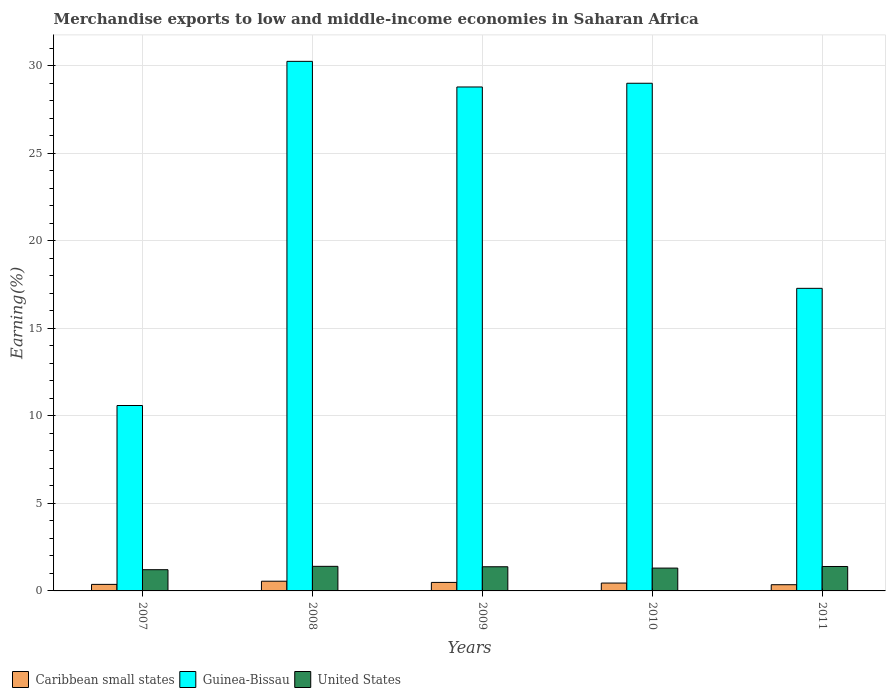How many different coloured bars are there?
Offer a terse response. 3. Are the number of bars per tick equal to the number of legend labels?
Give a very brief answer. Yes. What is the label of the 5th group of bars from the left?
Offer a terse response. 2011. In how many cases, is the number of bars for a given year not equal to the number of legend labels?
Keep it short and to the point. 0. What is the percentage of amount earned from merchandise exports in Guinea-Bissau in 2010?
Provide a succinct answer. 29. Across all years, what is the maximum percentage of amount earned from merchandise exports in Guinea-Bissau?
Keep it short and to the point. 30.25. Across all years, what is the minimum percentage of amount earned from merchandise exports in United States?
Offer a terse response. 1.21. In which year was the percentage of amount earned from merchandise exports in United States minimum?
Provide a short and direct response. 2007. What is the total percentage of amount earned from merchandise exports in Caribbean small states in the graph?
Your answer should be compact. 2.22. What is the difference between the percentage of amount earned from merchandise exports in Guinea-Bissau in 2007 and that in 2011?
Give a very brief answer. -6.69. What is the difference between the percentage of amount earned from merchandise exports in Guinea-Bissau in 2008 and the percentage of amount earned from merchandise exports in Caribbean small states in 2010?
Offer a terse response. 29.81. What is the average percentage of amount earned from merchandise exports in Caribbean small states per year?
Give a very brief answer. 0.44. In the year 2009, what is the difference between the percentage of amount earned from merchandise exports in United States and percentage of amount earned from merchandise exports in Caribbean small states?
Your answer should be very brief. 0.89. What is the ratio of the percentage of amount earned from merchandise exports in Guinea-Bissau in 2008 to that in 2009?
Offer a very short reply. 1.05. What is the difference between the highest and the second highest percentage of amount earned from merchandise exports in Caribbean small states?
Provide a succinct answer. 0.07. What is the difference between the highest and the lowest percentage of amount earned from merchandise exports in Guinea-Bissau?
Make the answer very short. 19.66. Is the sum of the percentage of amount earned from merchandise exports in Guinea-Bissau in 2007 and 2011 greater than the maximum percentage of amount earned from merchandise exports in Caribbean small states across all years?
Make the answer very short. Yes. What does the 2nd bar from the left in 2008 represents?
Ensure brevity in your answer.  Guinea-Bissau. What does the 2nd bar from the right in 2010 represents?
Make the answer very short. Guinea-Bissau. Is it the case that in every year, the sum of the percentage of amount earned from merchandise exports in United States and percentage of amount earned from merchandise exports in Guinea-Bissau is greater than the percentage of amount earned from merchandise exports in Caribbean small states?
Make the answer very short. Yes. How many bars are there?
Ensure brevity in your answer.  15. Are the values on the major ticks of Y-axis written in scientific E-notation?
Make the answer very short. No. Does the graph contain any zero values?
Make the answer very short. No. Does the graph contain grids?
Your answer should be very brief. Yes. Where does the legend appear in the graph?
Provide a short and direct response. Bottom left. What is the title of the graph?
Provide a short and direct response. Merchandise exports to low and middle-income economies in Saharan Africa. Does "Saudi Arabia" appear as one of the legend labels in the graph?
Make the answer very short. No. What is the label or title of the X-axis?
Ensure brevity in your answer.  Years. What is the label or title of the Y-axis?
Keep it short and to the point. Earning(%). What is the Earning(%) of Caribbean small states in 2007?
Give a very brief answer. 0.37. What is the Earning(%) in Guinea-Bissau in 2007?
Make the answer very short. 10.59. What is the Earning(%) in United States in 2007?
Your response must be concise. 1.21. What is the Earning(%) in Caribbean small states in 2008?
Make the answer very short. 0.55. What is the Earning(%) in Guinea-Bissau in 2008?
Offer a very short reply. 30.25. What is the Earning(%) of United States in 2008?
Provide a succinct answer. 1.4. What is the Earning(%) in Caribbean small states in 2009?
Give a very brief answer. 0.49. What is the Earning(%) of Guinea-Bissau in 2009?
Your answer should be compact. 28.79. What is the Earning(%) in United States in 2009?
Provide a short and direct response. 1.38. What is the Earning(%) in Caribbean small states in 2010?
Provide a short and direct response. 0.45. What is the Earning(%) of Guinea-Bissau in 2010?
Give a very brief answer. 29. What is the Earning(%) of United States in 2010?
Provide a short and direct response. 1.3. What is the Earning(%) in Caribbean small states in 2011?
Give a very brief answer. 0.35. What is the Earning(%) in Guinea-Bissau in 2011?
Provide a short and direct response. 17.29. What is the Earning(%) of United States in 2011?
Give a very brief answer. 1.4. Across all years, what is the maximum Earning(%) in Caribbean small states?
Provide a short and direct response. 0.55. Across all years, what is the maximum Earning(%) in Guinea-Bissau?
Provide a short and direct response. 30.25. Across all years, what is the maximum Earning(%) of United States?
Make the answer very short. 1.4. Across all years, what is the minimum Earning(%) in Caribbean small states?
Your response must be concise. 0.35. Across all years, what is the minimum Earning(%) of Guinea-Bissau?
Make the answer very short. 10.59. Across all years, what is the minimum Earning(%) of United States?
Offer a terse response. 1.21. What is the total Earning(%) in Caribbean small states in the graph?
Your answer should be very brief. 2.22. What is the total Earning(%) in Guinea-Bissau in the graph?
Offer a very short reply. 115.93. What is the total Earning(%) of United States in the graph?
Offer a terse response. 6.7. What is the difference between the Earning(%) of Caribbean small states in 2007 and that in 2008?
Your answer should be compact. -0.18. What is the difference between the Earning(%) of Guinea-Bissau in 2007 and that in 2008?
Offer a very short reply. -19.66. What is the difference between the Earning(%) of United States in 2007 and that in 2008?
Ensure brevity in your answer.  -0.19. What is the difference between the Earning(%) in Caribbean small states in 2007 and that in 2009?
Provide a short and direct response. -0.11. What is the difference between the Earning(%) in Guinea-Bissau in 2007 and that in 2009?
Make the answer very short. -18.2. What is the difference between the Earning(%) of United States in 2007 and that in 2009?
Offer a very short reply. -0.17. What is the difference between the Earning(%) of Caribbean small states in 2007 and that in 2010?
Ensure brevity in your answer.  -0.08. What is the difference between the Earning(%) of Guinea-Bissau in 2007 and that in 2010?
Your answer should be very brief. -18.41. What is the difference between the Earning(%) of United States in 2007 and that in 2010?
Give a very brief answer. -0.09. What is the difference between the Earning(%) in Caribbean small states in 2007 and that in 2011?
Offer a terse response. 0.02. What is the difference between the Earning(%) of Guinea-Bissau in 2007 and that in 2011?
Your answer should be very brief. -6.69. What is the difference between the Earning(%) of United States in 2007 and that in 2011?
Give a very brief answer. -0.18. What is the difference between the Earning(%) of Caribbean small states in 2008 and that in 2009?
Ensure brevity in your answer.  0.07. What is the difference between the Earning(%) in Guinea-Bissau in 2008 and that in 2009?
Your answer should be compact. 1.46. What is the difference between the Earning(%) of United States in 2008 and that in 2009?
Your answer should be compact. 0.02. What is the difference between the Earning(%) in Caribbean small states in 2008 and that in 2010?
Ensure brevity in your answer.  0.11. What is the difference between the Earning(%) in Guinea-Bissau in 2008 and that in 2010?
Your answer should be compact. 1.25. What is the difference between the Earning(%) of United States in 2008 and that in 2010?
Offer a very short reply. 0.1. What is the difference between the Earning(%) in Caribbean small states in 2008 and that in 2011?
Your response must be concise. 0.2. What is the difference between the Earning(%) in Guinea-Bissau in 2008 and that in 2011?
Your response must be concise. 12.97. What is the difference between the Earning(%) in United States in 2008 and that in 2011?
Offer a very short reply. 0.01. What is the difference between the Earning(%) of Caribbean small states in 2009 and that in 2010?
Provide a short and direct response. 0.04. What is the difference between the Earning(%) in Guinea-Bissau in 2009 and that in 2010?
Offer a very short reply. -0.21. What is the difference between the Earning(%) of United States in 2009 and that in 2010?
Offer a terse response. 0.08. What is the difference between the Earning(%) in Caribbean small states in 2009 and that in 2011?
Provide a succinct answer. 0.13. What is the difference between the Earning(%) of Guinea-Bissau in 2009 and that in 2011?
Provide a short and direct response. 11.5. What is the difference between the Earning(%) of United States in 2009 and that in 2011?
Provide a short and direct response. -0.01. What is the difference between the Earning(%) in Caribbean small states in 2010 and that in 2011?
Your response must be concise. 0.09. What is the difference between the Earning(%) of Guinea-Bissau in 2010 and that in 2011?
Ensure brevity in your answer.  11.72. What is the difference between the Earning(%) of United States in 2010 and that in 2011?
Offer a terse response. -0.09. What is the difference between the Earning(%) of Caribbean small states in 2007 and the Earning(%) of Guinea-Bissau in 2008?
Your answer should be compact. -29.88. What is the difference between the Earning(%) of Caribbean small states in 2007 and the Earning(%) of United States in 2008?
Make the answer very short. -1.03. What is the difference between the Earning(%) in Guinea-Bissau in 2007 and the Earning(%) in United States in 2008?
Your answer should be very brief. 9.19. What is the difference between the Earning(%) in Caribbean small states in 2007 and the Earning(%) in Guinea-Bissau in 2009?
Provide a short and direct response. -28.42. What is the difference between the Earning(%) of Caribbean small states in 2007 and the Earning(%) of United States in 2009?
Offer a very short reply. -1.01. What is the difference between the Earning(%) in Guinea-Bissau in 2007 and the Earning(%) in United States in 2009?
Keep it short and to the point. 9.21. What is the difference between the Earning(%) in Caribbean small states in 2007 and the Earning(%) in Guinea-Bissau in 2010?
Ensure brevity in your answer.  -28.63. What is the difference between the Earning(%) of Caribbean small states in 2007 and the Earning(%) of United States in 2010?
Give a very brief answer. -0.93. What is the difference between the Earning(%) in Guinea-Bissau in 2007 and the Earning(%) in United States in 2010?
Make the answer very short. 9.29. What is the difference between the Earning(%) of Caribbean small states in 2007 and the Earning(%) of Guinea-Bissau in 2011?
Offer a very short reply. -16.91. What is the difference between the Earning(%) of Caribbean small states in 2007 and the Earning(%) of United States in 2011?
Give a very brief answer. -1.02. What is the difference between the Earning(%) in Guinea-Bissau in 2007 and the Earning(%) in United States in 2011?
Keep it short and to the point. 9.2. What is the difference between the Earning(%) of Caribbean small states in 2008 and the Earning(%) of Guinea-Bissau in 2009?
Ensure brevity in your answer.  -28.24. What is the difference between the Earning(%) of Caribbean small states in 2008 and the Earning(%) of United States in 2009?
Your response must be concise. -0.83. What is the difference between the Earning(%) in Guinea-Bissau in 2008 and the Earning(%) in United States in 2009?
Your response must be concise. 28.87. What is the difference between the Earning(%) in Caribbean small states in 2008 and the Earning(%) in Guinea-Bissau in 2010?
Make the answer very short. -28.45. What is the difference between the Earning(%) in Caribbean small states in 2008 and the Earning(%) in United States in 2010?
Ensure brevity in your answer.  -0.75. What is the difference between the Earning(%) of Guinea-Bissau in 2008 and the Earning(%) of United States in 2010?
Ensure brevity in your answer.  28.95. What is the difference between the Earning(%) of Caribbean small states in 2008 and the Earning(%) of Guinea-Bissau in 2011?
Ensure brevity in your answer.  -16.73. What is the difference between the Earning(%) in Caribbean small states in 2008 and the Earning(%) in United States in 2011?
Offer a terse response. -0.84. What is the difference between the Earning(%) of Guinea-Bissau in 2008 and the Earning(%) of United States in 2011?
Ensure brevity in your answer.  28.86. What is the difference between the Earning(%) of Caribbean small states in 2009 and the Earning(%) of Guinea-Bissau in 2010?
Keep it short and to the point. -28.52. What is the difference between the Earning(%) of Caribbean small states in 2009 and the Earning(%) of United States in 2010?
Give a very brief answer. -0.82. What is the difference between the Earning(%) in Guinea-Bissau in 2009 and the Earning(%) in United States in 2010?
Provide a succinct answer. 27.49. What is the difference between the Earning(%) in Caribbean small states in 2009 and the Earning(%) in Guinea-Bissau in 2011?
Keep it short and to the point. -16.8. What is the difference between the Earning(%) of Caribbean small states in 2009 and the Earning(%) of United States in 2011?
Your answer should be very brief. -0.91. What is the difference between the Earning(%) in Guinea-Bissau in 2009 and the Earning(%) in United States in 2011?
Offer a very short reply. 27.4. What is the difference between the Earning(%) in Caribbean small states in 2010 and the Earning(%) in Guinea-Bissau in 2011?
Provide a succinct answer. -16.84. What is the difference between the Earning(%) in Caribbean small states in 2010 and the Earning(%) in United States in 2011?
Give a very brief answer. -0.95. What is the difference between the Earning(%) in Guinea-Bissau in 2010 and the Earning(%) in United States in 2011?
Ensure brevity in your answer.  27.61. What is the average Earning(%) of Caribbean small states per year?
Provide a short and direct response. 0.44. What is the average Earning(%) of Guinea-Bissau per year?
Provide a short and direct response. 23.19. What is the average Earning(%) of United States per year?
Offer a very short reply. 1.34. In the year 2007, what is the difference between the Earning(%) in Caribbean small states and Earning(%) in Guinea-Bissau?
Offer a very short reply. -10.22. In the year 2007, what is the difference between the Earning(%) of Caribbean small states and Earning(%) of United States?
Make the answer very short. -0.84. In the year 2007, what is the difference between the Earning(%) of Guinea-Bissau and Earning(%) of United States?
Offer a terse response. 9.38. In the year 2008, what is the difference between the Earning(%) of Caribbean small states and Earning(%) of Guinea-Bissau?
Offer a terse response. -29.7. In the year 2008, what is the difference between the Earning(%) in Caribbean small states and Earning(%) in United States?
Your answer should be compact. -0.85. In the year 2008, what is the difference between the Earning(%) of Guinea-Bissau and Earning(%) of United States?
Keep it short and to the point. 28.85. In the year 2009, what is the difference between the Earning(%) in Caribbean small states and Earning(%) in Guinea-Bissau?
Make the answer very short. -28.31. In the year 2009, what is the difference between the Earning(%) of Caribbean small states and Earning(%) of United States?
Provide a succinct answer. -0.89. In the year 2009, what is the difference between the Earning(%) in Guinea-Bissau and Earning(%) in United States?
Keep it short and to the point. 27.41. In the year 2010, what is the difference between the Earning(%) of Caribbean small states and Earning(%) of Guinea-Bissau?
Offer a terse response. -28.55. In the year 2010, what is the difference between the Earning(%) in Caribbean small states and Earning(%) in United States?
Your response must be concise. -0.86. In the year 2010, what is the difference between the Earning(%) in Guinea-Bissau and Earning(%) in United States?
Offer a terse response. 27.7. In the year 2011, what is the difference between the Earning(%) in Caribbean small states and Earning(%) in Guinea-Bissau?
Your response must be concise. -16.93. In the year 2011, what is the difference between the Earning(%) of Caribbean small states and Earning(%) of United States?
Provide a succinct answer. -1.04. In the year 2011, what is the difference between the Earning(%) in Guinea-Bissau and Earning(%) in United States?
Provide a short and direct response. 15.89. What is the ratio of the Earning(%) in Caribbean small states in 2007 to that in 2008?
Give a very brief answer. 0.67. What is the ratio of the Earning(%) of Guinea-Bissau in 2007 to that in 2008?
Your answer should be compact. 0.35. What is the ratio of the Earning(%) of United States in 2007 to that in 2008?
Provide a succinct answer. 0.86. What is the ratio of the Earning(%) in Caribbean small states in 2007 to that in 2009?
Offer a terse response. 0.77. What is the ratio of the Earning(%) of Guinea-Bissau in 2007 to that in 2009?
Provide a short and direct response. 0.37. What is the ratio of the Earning(%) of United States in 2007 to that in 2009?
Offer a terse response. 0.88. What is the ratio of the Earning(%) in Caribbean small states in 2007 to that in 2010?
Your answer should be very brief. 0.83. What is the ratio of the Earning(%) of Guinea-Bissau in 2007 to that in 2010?
Provide a short and direct response. 0.37. What is the ratio of the Earning(%) in United States in 2007 to that in 2010?
Offer a very short reply. 0.93. What is the ratio of the Earning(%) in Caribbean small states in 2007 to that in 2011?
Ensure brevity in your answer.  1.05. What is the ratio of the Earning(%) in Guinea-Bissau in 2007 to that in 2011?
Your response must be concise. 0.61. What is the ratio of the Earning(%) in United States in 2007 to that in 2011?
Offer a very short reply. 0.87. What is the ratio of the Earning(%) in Caribbean small states in 2008 to that in 2009?
Offer a terse response. 1.14. What is the ratio of the Earning(%) of Guinea-Bissau in 2008 to that in 2009?
Keep it short and to the point. 1.05. What is the ratio of the Earning(%) in United States in 2008 to that in 2009?
Your answer should be compact. 1.02. What is the ratio of the Earning(%) in Caribbean small states in 2008 to that in 2010?
Make the answer very short. 1.24. What is the ratio of the Earning(%) of Guinea-Bissau in 2008 to that in 2010?
Offer a very short reply. 1.04. What is the ratio of the Earning(%) in United States in 2008 to that in 2010?
Offer a terse response. 1.08. What is the ratio of the Earning(%) of Caribbean small states in 2008 to that in 2011?
Your answer should be compact. 1.57. What is the ratio of the Earning(%) of Guinea-Bissau in 2008 to that in 2011?
Give a very brief answer. 1.75. What is the ratio of the Earning(%) of United States in 2008 to that in 2011?
Your answer should be very brief. 1.01. What is the ratio of the Earning(%) in Caribbean small states in 2009 to that in 2010?
Offer a terse response. 1.08. What is the ratio of the Earning(%) of Guinea-Bissau in 2009 to that in 2010?
Provide a short and direct response. 0.99. What is the ratio of the Earning(%) of United States in 2009 to that in 2010?
Your response must be concise. 1.06. What is the ratio of the Earning(%) of Caribbean small states in 2009 to that in 2011?
Ensure brevity in your answer.  1.37. What is the ratio of the Earning(%) of Guinea-Bissau in 2009 to that in 2011?
Keep it short and to the point. 1.67. What is the ratio of the Earning(%) of Caribbean small states in 2010 to that in 2011?
Provide a succinct answer. 1.27. What is the ratio of the Earning(%) of Guinea-Bissau in 2010 to that in 2011?
Make the answer very short. 1.68. What is the ratio of the Earning(%) in United States in 2010 to that in 2011?
Make the answer very short. 0.93. What is the difference between the highest and the second highest Earning(%) in Caribbean small states?
Provide a short and direct response. 0.07. What is the difference between the highest and the second highest Earning(%) of Guinea-Bissau?
Offer a terse response. 1.25. What is the difference between the highest and the second highest Earning(%) in United States?
Keep it short and to the point. 0.01. What is the difference between the highest and the lowest Earning(%) in Caribbean small states?
Ensure brevity in your answer.  0.2. What is the difference between the highest and the lowest Earning(%) in Guinea-Bissau?
Provide a succinct answer. 19.66. What is the difference between the highest and the lowest Earning(%) in United States?
Your answer should be very brief. 0.19. 